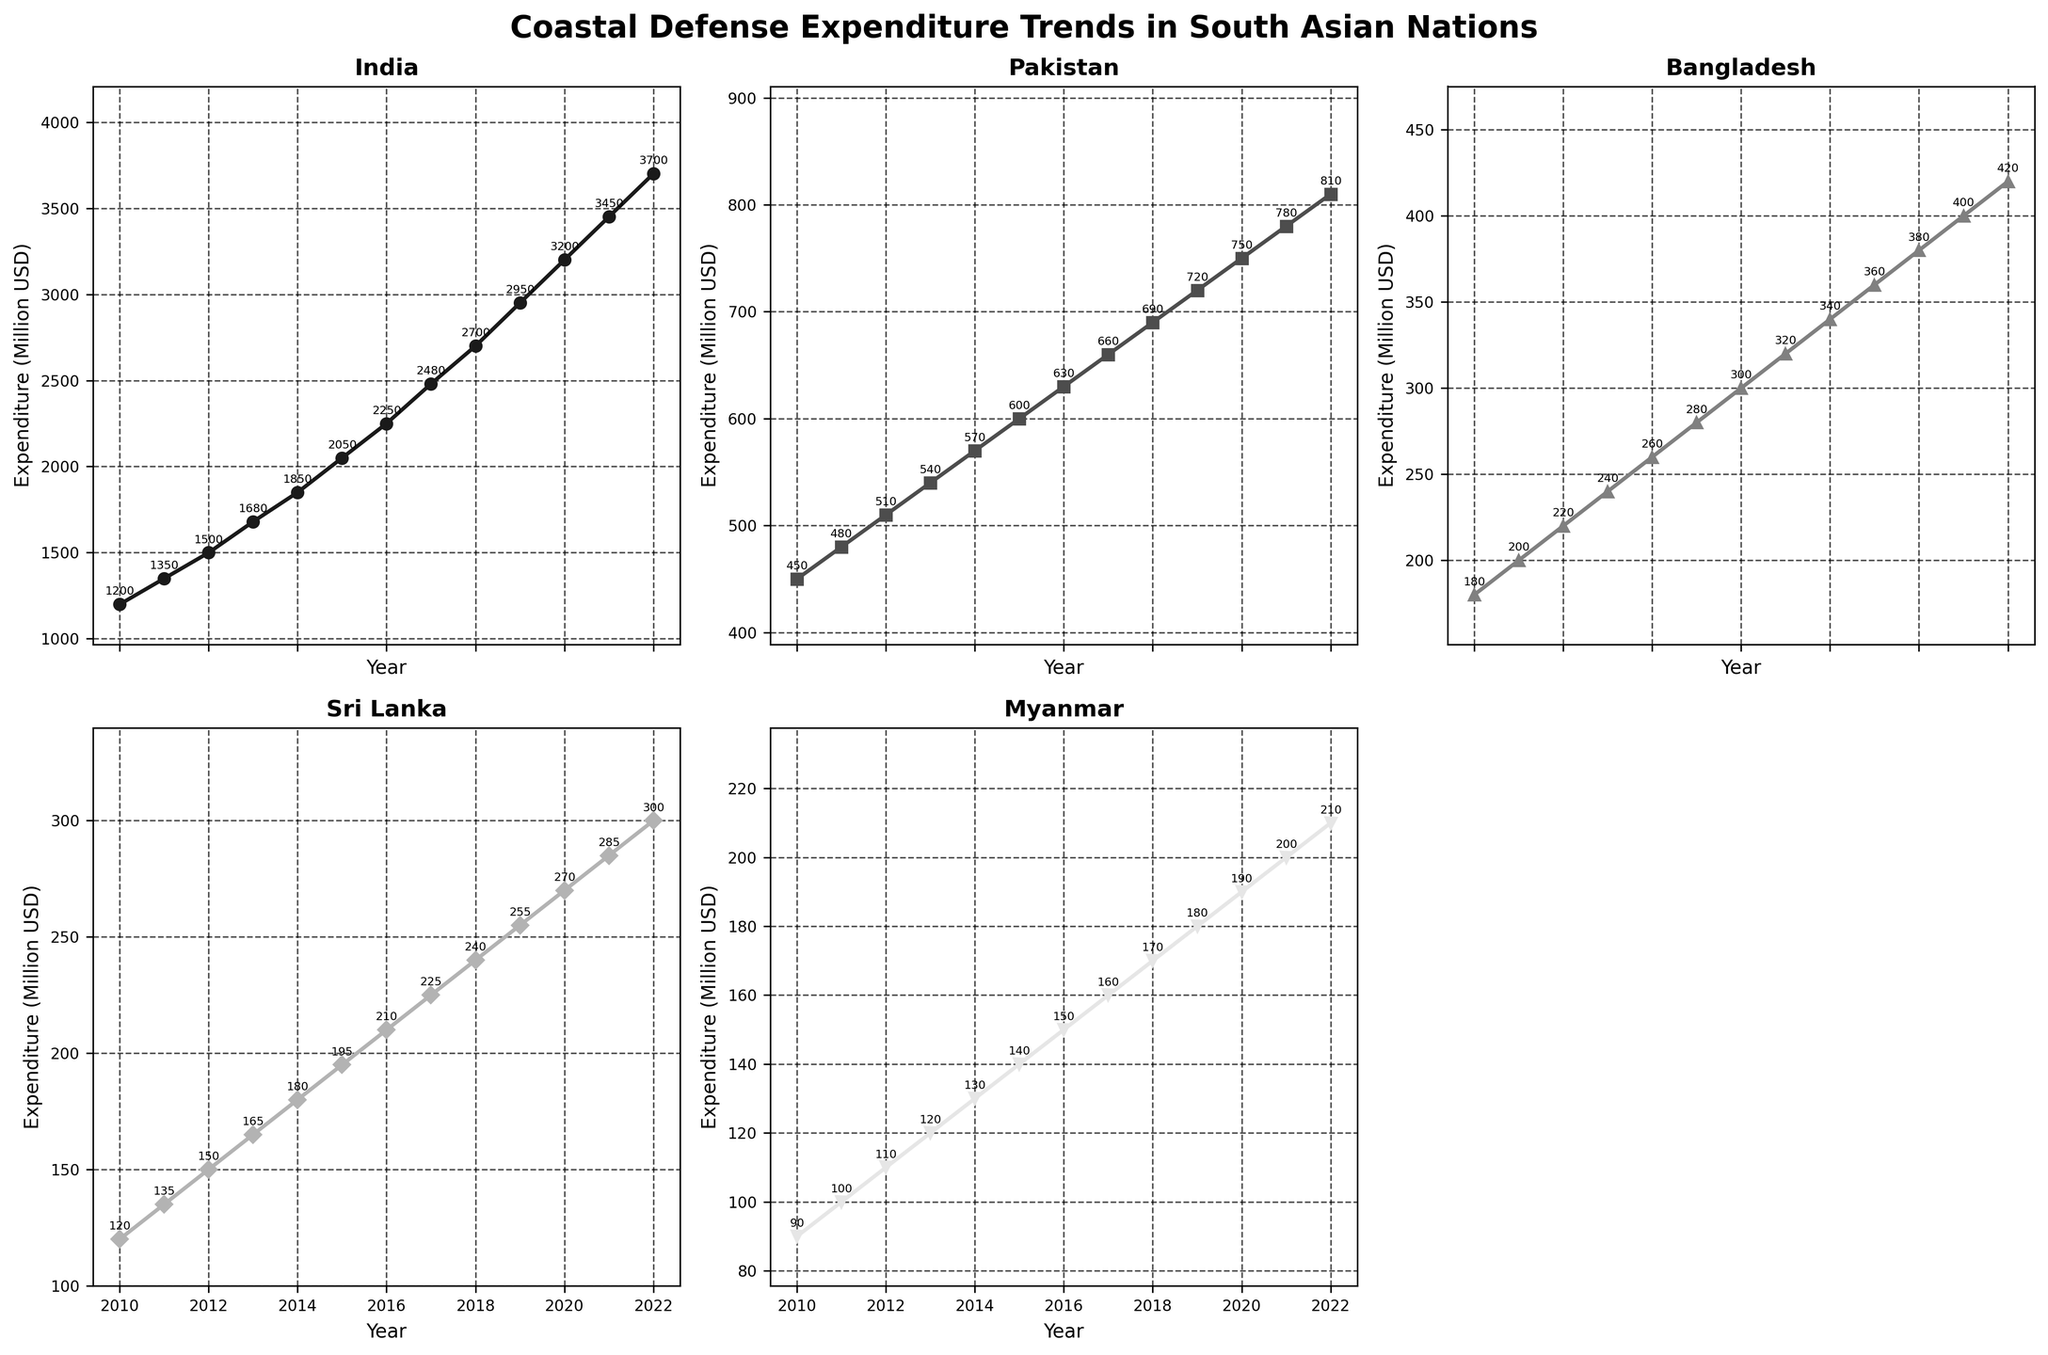What is the overall trend in India's coastal defense expenditure from 2010 to 2022? The plot for India shows a continuous upward trend in expenditure from 2010 to 2022. Each subsequent year has a higher expenditure than the previous year, indicating a consistent increase.
Answer: Consistent increase Which country had the lowest coastal defense expenditure in 2022? The subplot for Myanmar shows that it has the lowest expenditure among the given countries in 2022. This can be observed by comparing the endpoint values on all subplots.
Answer: Myanmar How does Pakistan's defense expenditure in 2011 compare to Bangladesh's in 2021? According to the figure, Pakistan's expenditure in 2011 is 480 million USD, while Bangladesh's expenditure in 2021 is 400 million USD. By comparing these values, we see that Pakistan's 2011 expenditure is higher.
Answer: Pakistan's is higher What is the difference in coastal defense expenditure between Sri Lanka and Myanmar in 2020? From the plots, Sri Lanka's expenditure in 2020 is 270 million USD, and Myanmar's is 190 million USD. The difference is calculated as 270 - 190 = 80 million USD.
Answer: 80 million USD Which country had the steepest increase in coastal defense expenditure over the entire period from 2010 to 2022? By observing the slopes of the lines in each subplot, it's evident that India shows the steepest upward trend. The expenditure increases more sharply compared to the other countries.
Answer: India Calculate the average annual increase in defense expenditure for Bangladesh between 2010 and 2022. To find the average annual increase, subtract Bangladesh's 2010 expenditure (180 million USD) from the 2022 expenditure (420 million USD) to get the total increase (420 - 180 = 240 million USD). Then, divide by the number of years (2022-2010 = 12 years). The average annual increase is 240 / 12 = 20 million USD.
Answer: 20 million USD In which year did India's coastal defense expenditure first exceed 2000 million USD? From the plot for India, we see that the expenditure first exceeds 2000 million USD in 2015, where it reaches 2050 million USD.
Answer: 2015 Between 2015 and 2020, which country had the smallest increase in coastal defense expenditure? By comparing the plots for the years 2015 to 2020 for each country, Myanmar shows the smallest increase. Its expenditure goes from 140 to 190 million USD, which is an increase of 50 million USD.
Answer: Myanmar What is the sum of coastal defense expenditures for Sri Lanka over the entire period from 2010 to 2022? Summing up Sri Lanka's expenditures: 120 + 135 + 150 + 165 + 180 + 195 + 210 + 225 + 240 + 255 + 270 + 285 + 300 = 3030 million USD.
Answer: 3030 million USD 